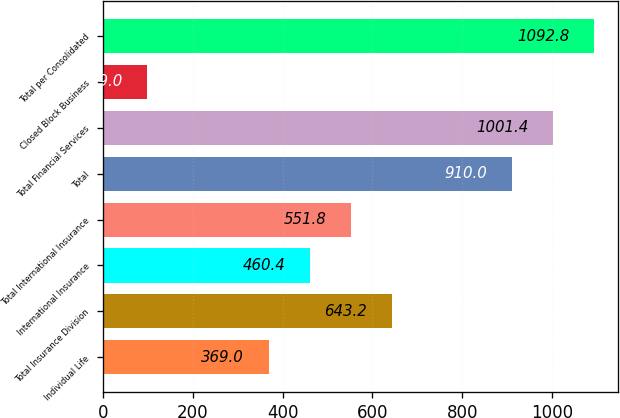Convert chart to OTSL. <chart><loc_0><loc_0><loc_500><loc_500><bar_chart><fcel>Individual Life<fcel>Total Insurance Division<fcel>International Insurance<fcel>Total International Insurance<fcel>Total<fcel>Total Financial Services<fcel>Closed Block Business<fcel>Total per Consolidated<nl><fcel>369<fcel>643.2<fcel>460.4<fcel>551.8<fcel>910<fcel>1001.4<fcel>99<fcel>1092.8<nl></chart> 